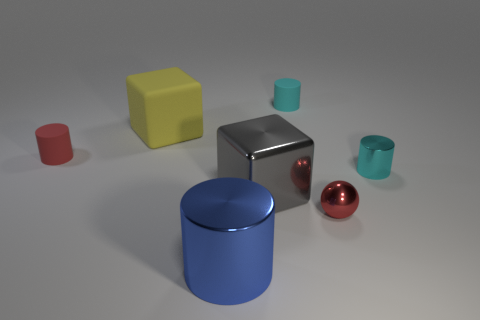What is the material of the large thing that is both behind the blue cylinder and in front of the small cyan metallic thing?
Your answer should be very brief. Metal. How many objects are either tiny gray cylinders or big shiny objects?
Your answer should be compact. 2. Is the number of small cylinders greater than the number of red rubber objects?
Offer a very short reply. Yes. There is a red thing that is right of the red thing left of the big yellow block; what is its size?
Offer a very short reply. Small. There is another big rubber thing that is the same shape as the gray object; what is its color?
Offer a terse response. Yellow. What is the size of the red ball?
Offer a very short reply. Small. What number of cubes are blue things or yellow things?
Offer a very short reply. 1. There is a red rubber object that is the same shape as the small cyan metal thing; what is its size?
Make the answer very short. Small. What number of tiny cyan cylinders are there?
Make the answer very short. 2. There is a small cyan rubber thing; is its shape the same as the tiny thing that is left of the blue object?
Your answer should be very brief. Yes. 